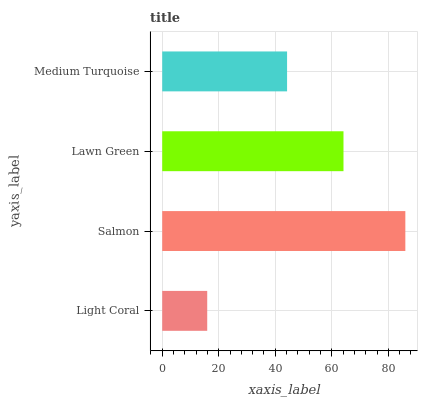Is Light Coral the minimum?
Answer yes or no. Yes. Is Salmon the maximum?
Answer yes or no. Yes. Is Lawn Green the minimum?
Answer yes or no. No. Is Lawn Green the maximum?
Answer yes or no. No. Is Salmon greater than Lawn Green?
Answer yes or no. Yes. Is Lawn Green less than Salmon?
Answer yes or no. Yes. Is Lawn Green greater than Salmon?
Answer yes or no. No. Is Salmon less than Lawn Green?
Answer yes or no. No. Is Lawn Green the high median?
Answer yes or no. Yes. Is Medium Turquoise the low median?
Answer yes or no. Yes. Is Medium Turquoise the high median?
Answer yes or no. No. Is Salmon the low median?
Answer yes or no. No. 